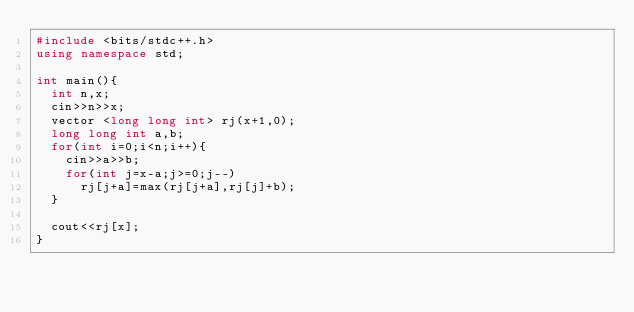<code> <loc_0><loc_0><loc_500><loc_500><_C++_>#include <bits/stdc++.h>
using namespace std;

int main(){
	int n,x;
	cin>>n>>x;
	vector <long long int> rj(x+1,0);
	long long int a,b;
	for(int i=0;i<n;i++){
		cin>>a>>b;
		for(int j=x-a;j>=0;j--)
			rj[j+a]=max(rj[j+a],rj[j]+b);
	}
	
	cout<<rj[x];
}</code> 